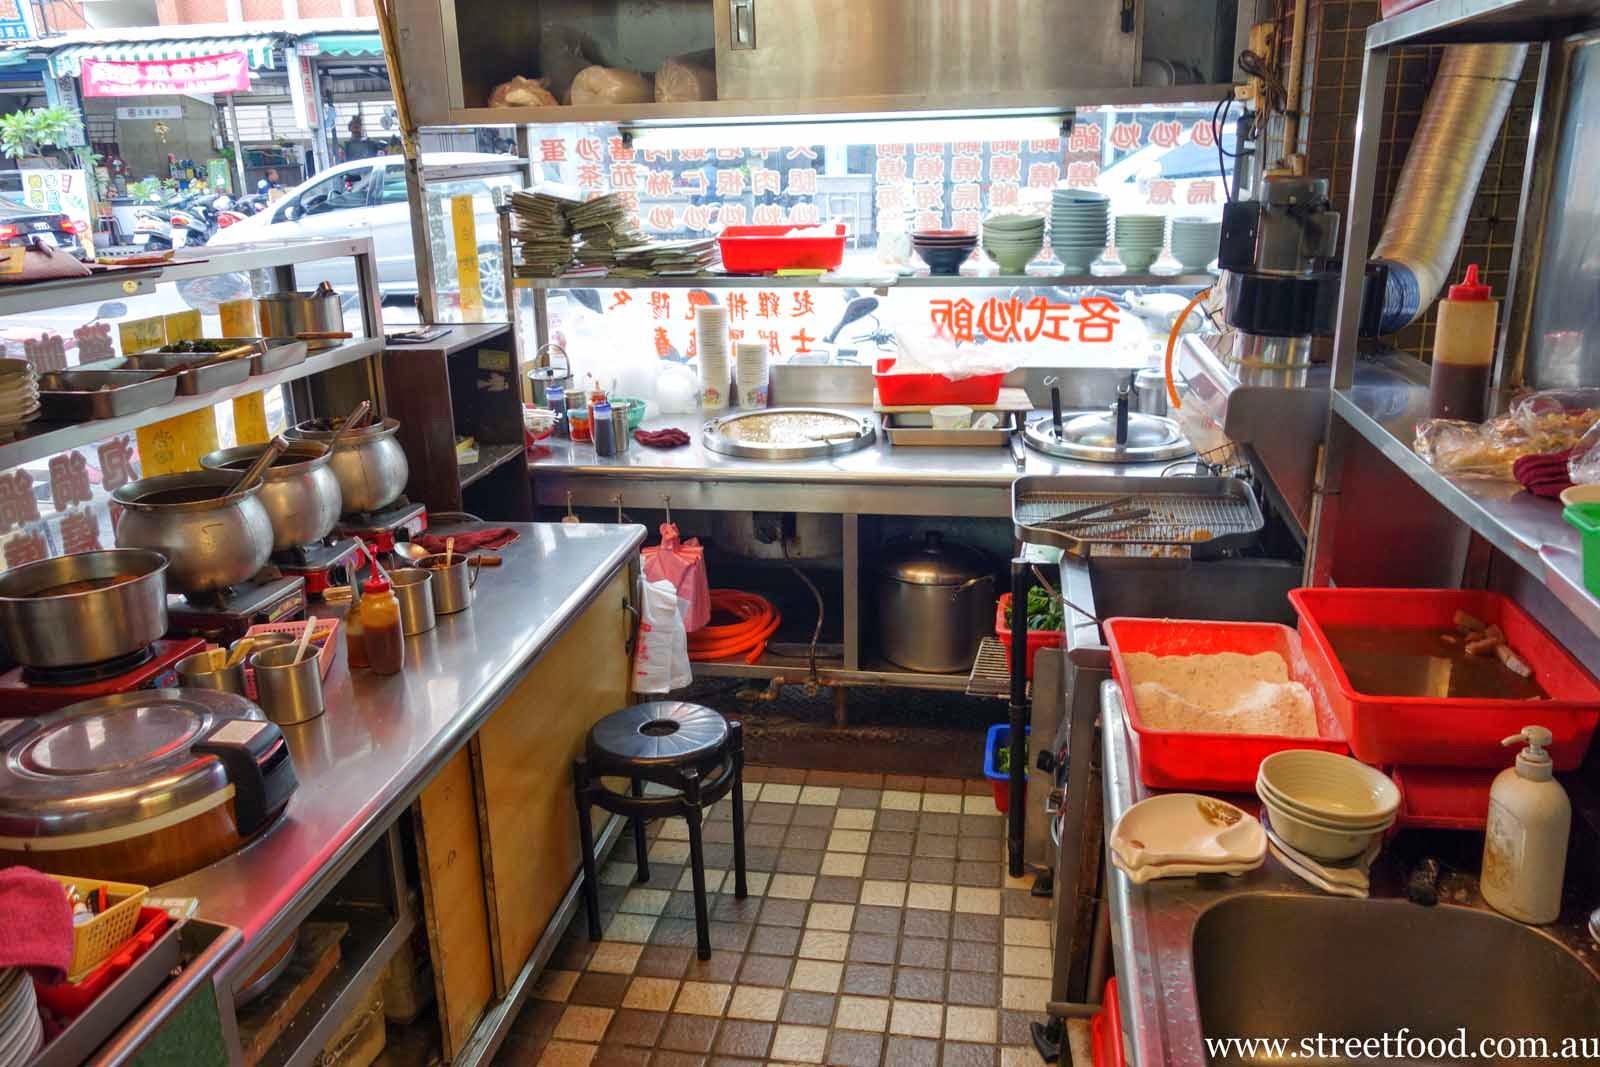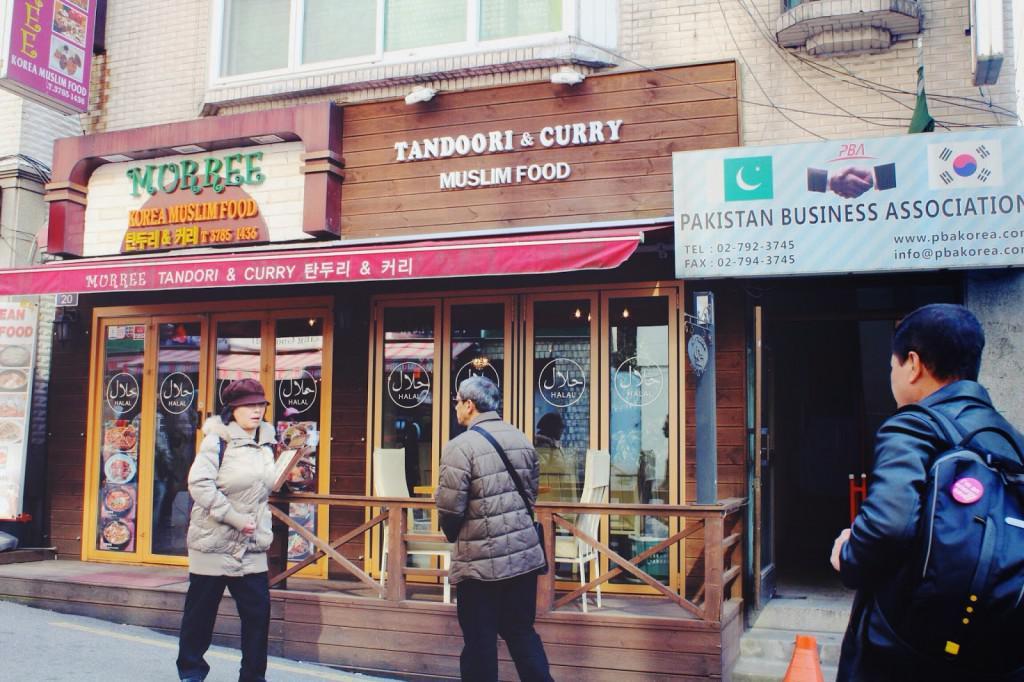The first image is the image on the left, the second image is the image on the right. Given the left and right images, does the statement "An image shows crowds on a street with a sign depicting a walking man on the left and a row of cylindrical lights under an overhanding roof on the right." hold true? Answer yes or no. No. The first image is the image on the left, the second image is the image on the right. Given the left and right images, does the statement "One of these shops has a visible coke machine in it." hold true? Answer yes or no. No. 